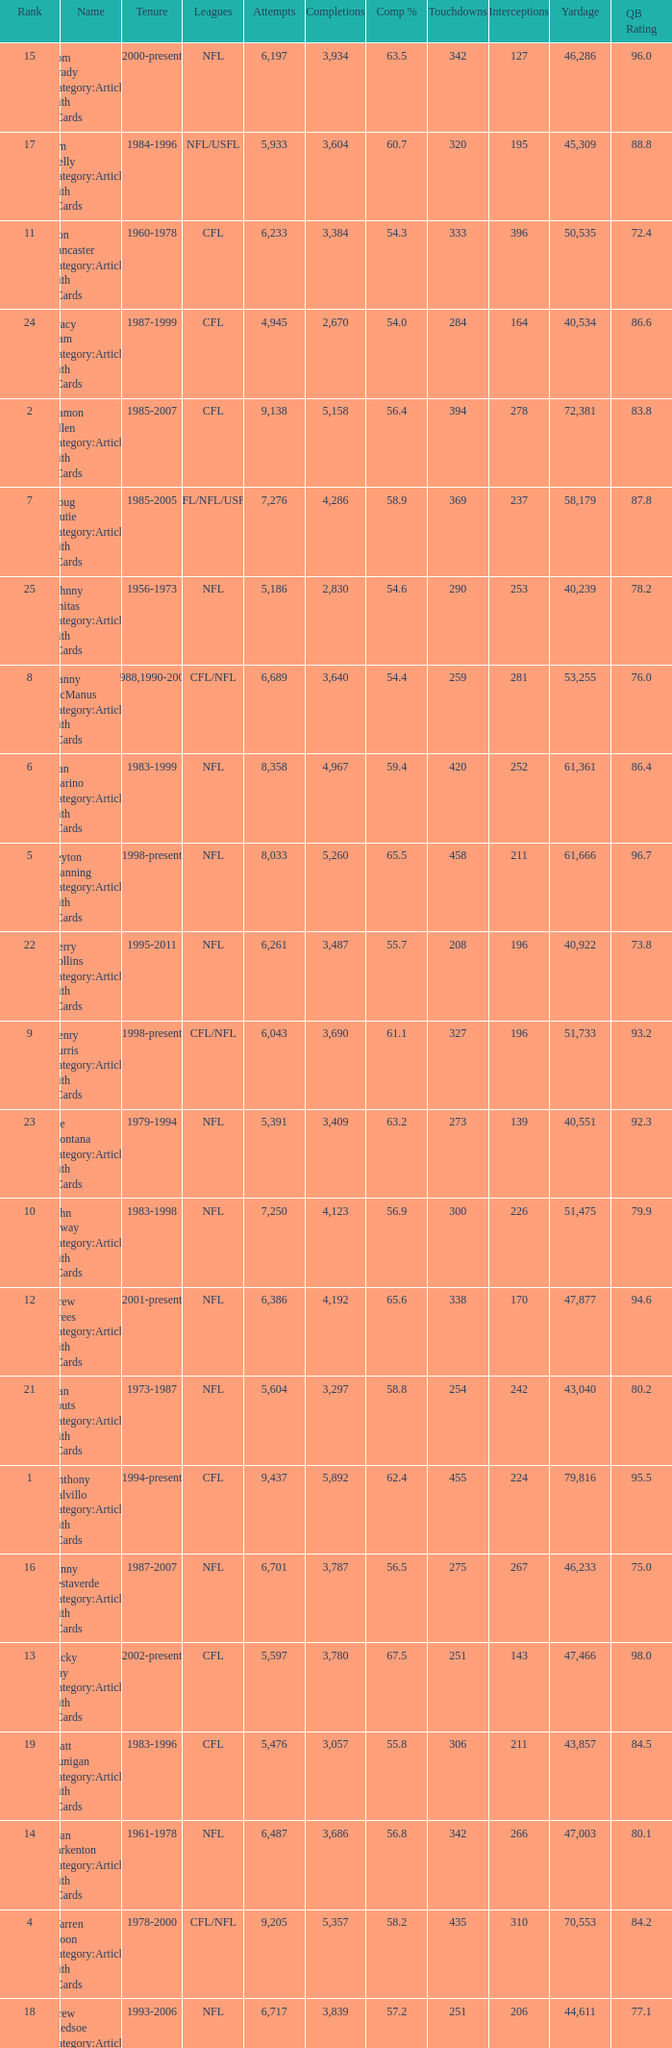What is the rank when there are more than 4,123 completion and the comp percentage is more than 65.6? None. 